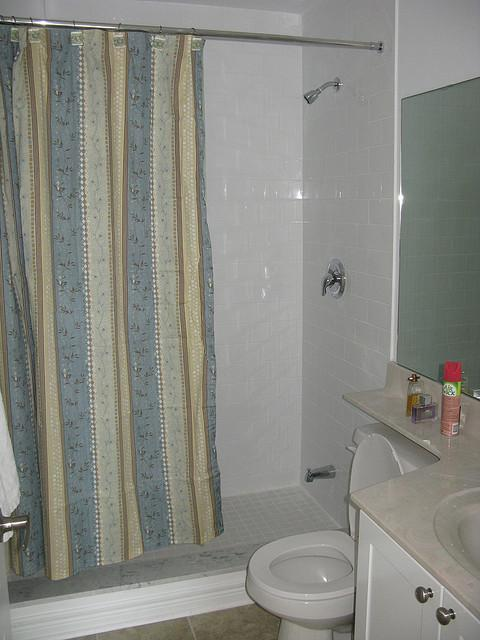What is in the can on the counter? air freshener 